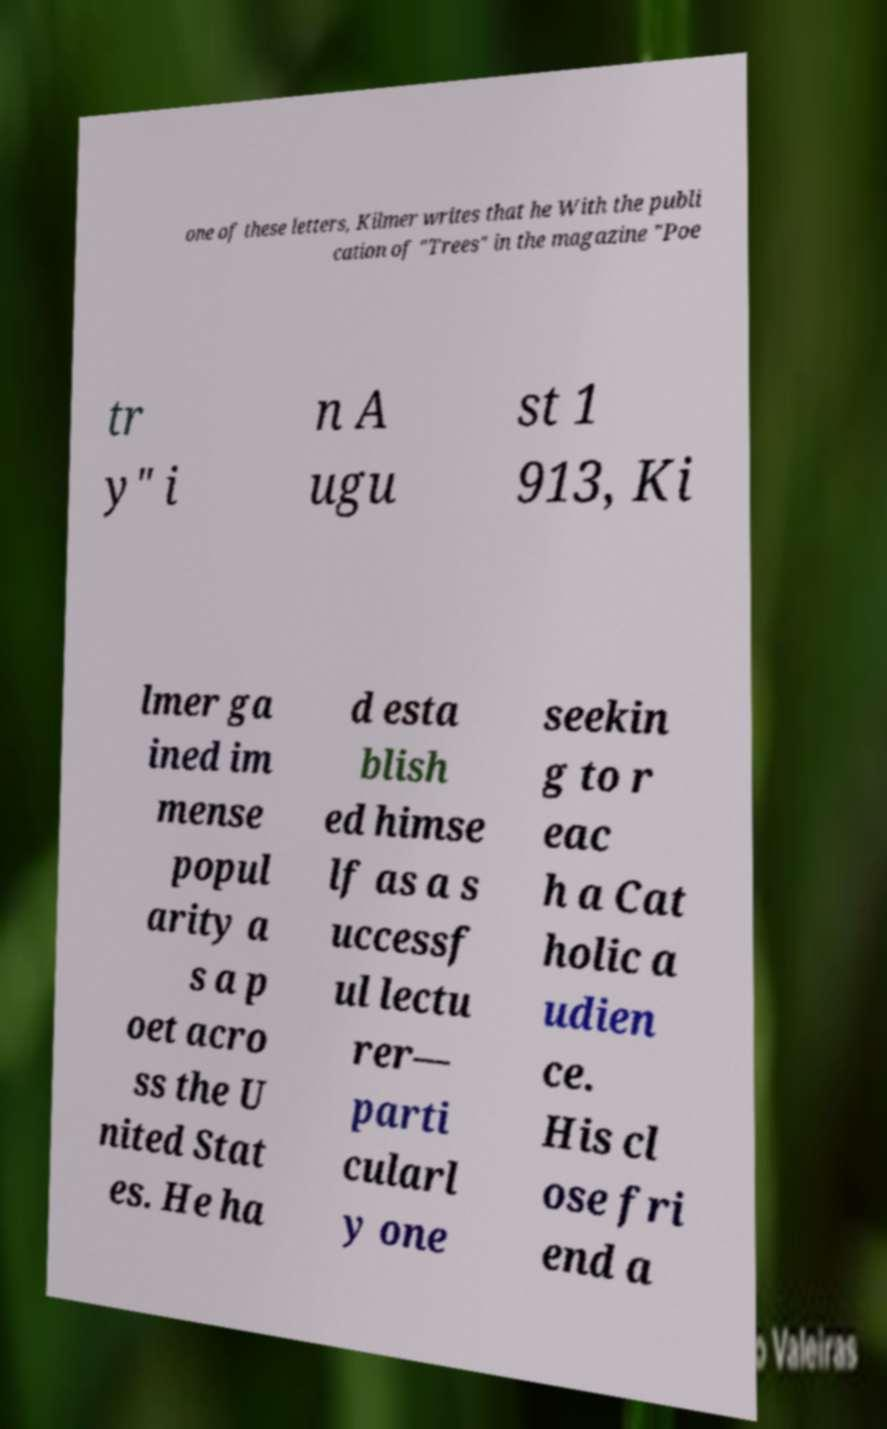Could you assist in decoding the text presented in this image and type it out clearly? one of these letters, Kilmer writes that he With the publi cation of "Trees" in the magazine "Poe tr y" i n A ugu st 1 913, Ki lmer ga ined im mense popul arity a s a p oet acro ss the U nited Stat es. He ha d esta blish ed himse lf as a s uccessf ul lectu rer— parti cularl y one seekin g to r eac h a Cat holic a udien ce. His cl ose fri end a 